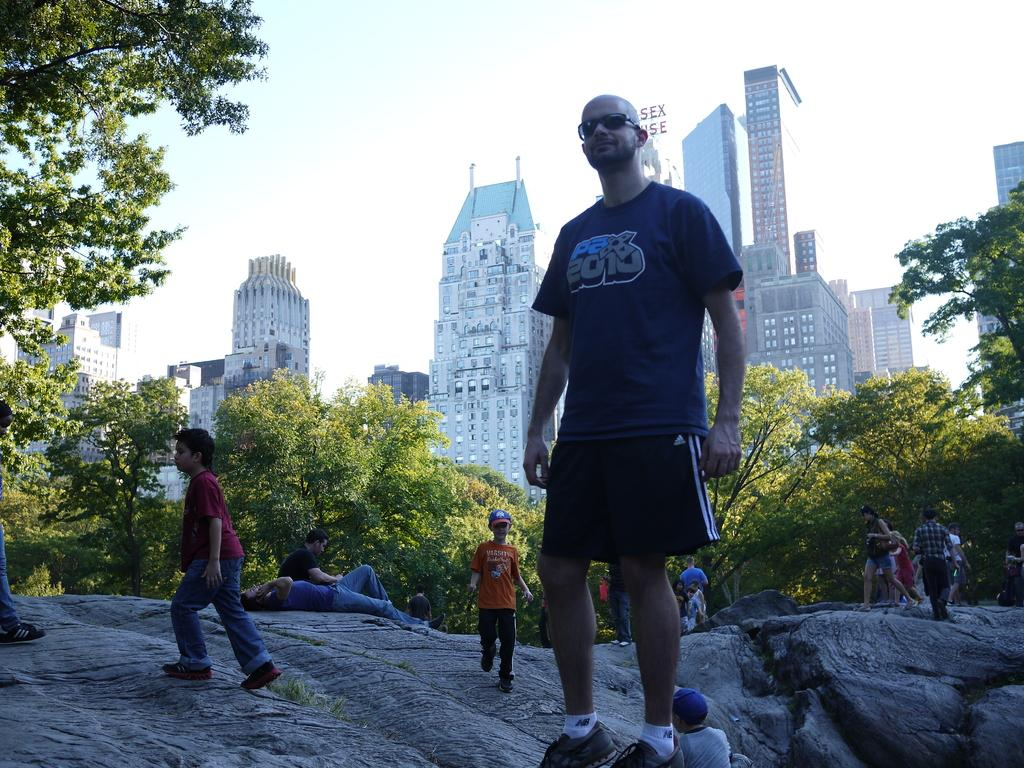How many people are in the image? There is a group of people in the image. Where are the people located in the image? The people are on rocks. What type of vegetation is present in the image? There are trees in the image. What can be seen in the background of the image? There are buildings and the sky visible in the background of the image. What type of tub is visible in the image? There is no tub present in the image. 